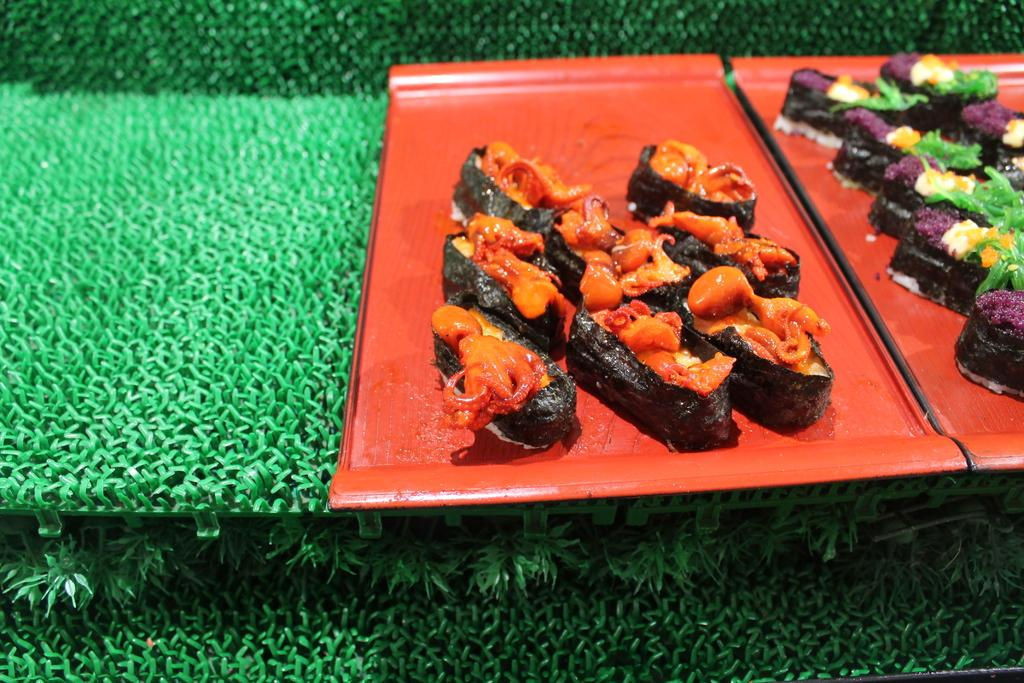What is present in the image related to food? There are food items in the image. How are the food items arranged in the image? The food items are placed on two trays. What is the color of the mat on which the trays are placed? The trays are on a green color mat. What type of property can be seen in the background of the image? There is no property visible in the image; it only shows food items on trays placed on a green color mat. 